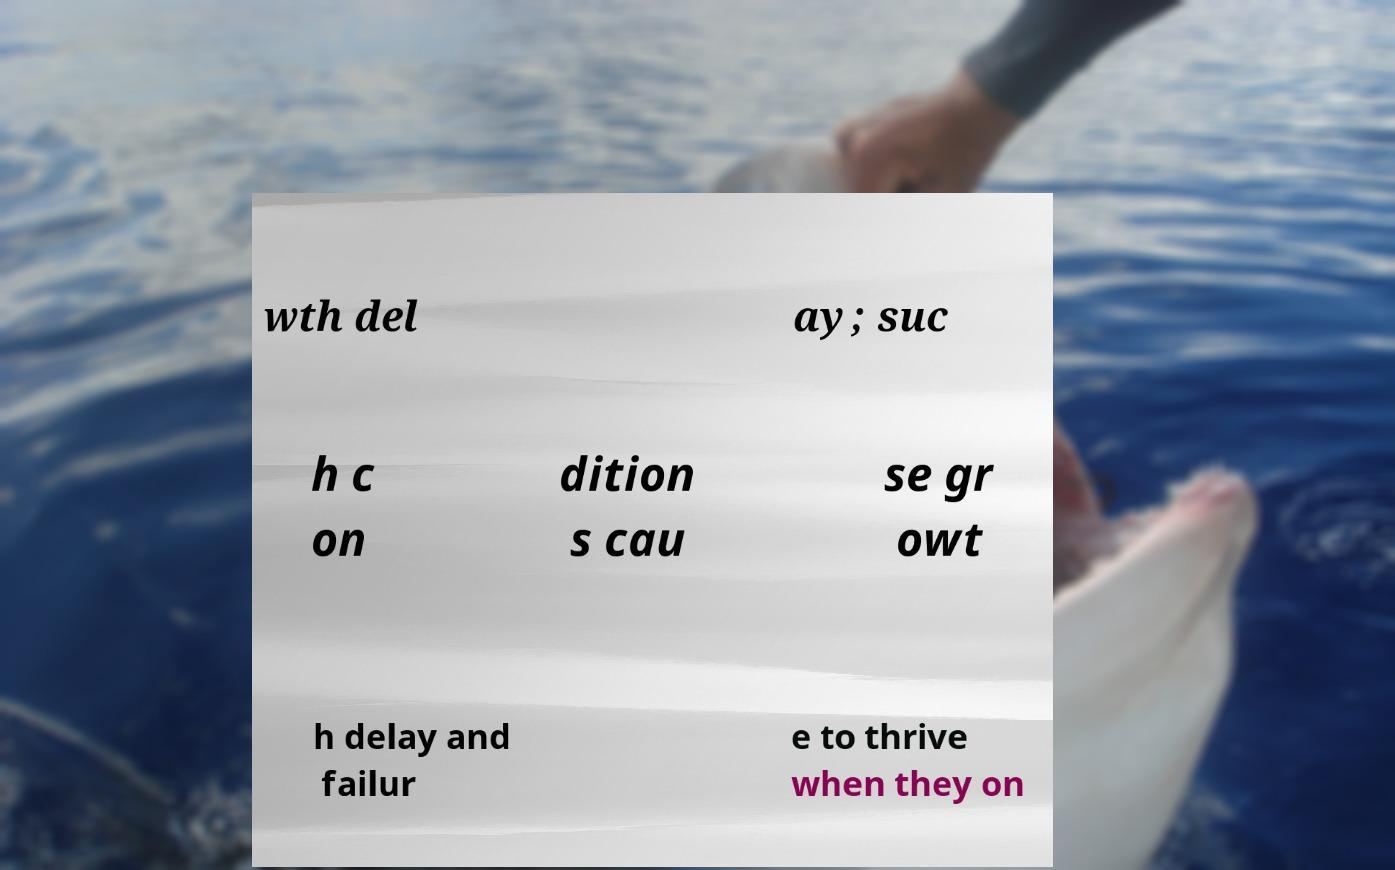Please identify and transcribe the text found in this image. wth del ay; suc h c on dition s cau se gr owt h delay and failur e to thrive when they on 